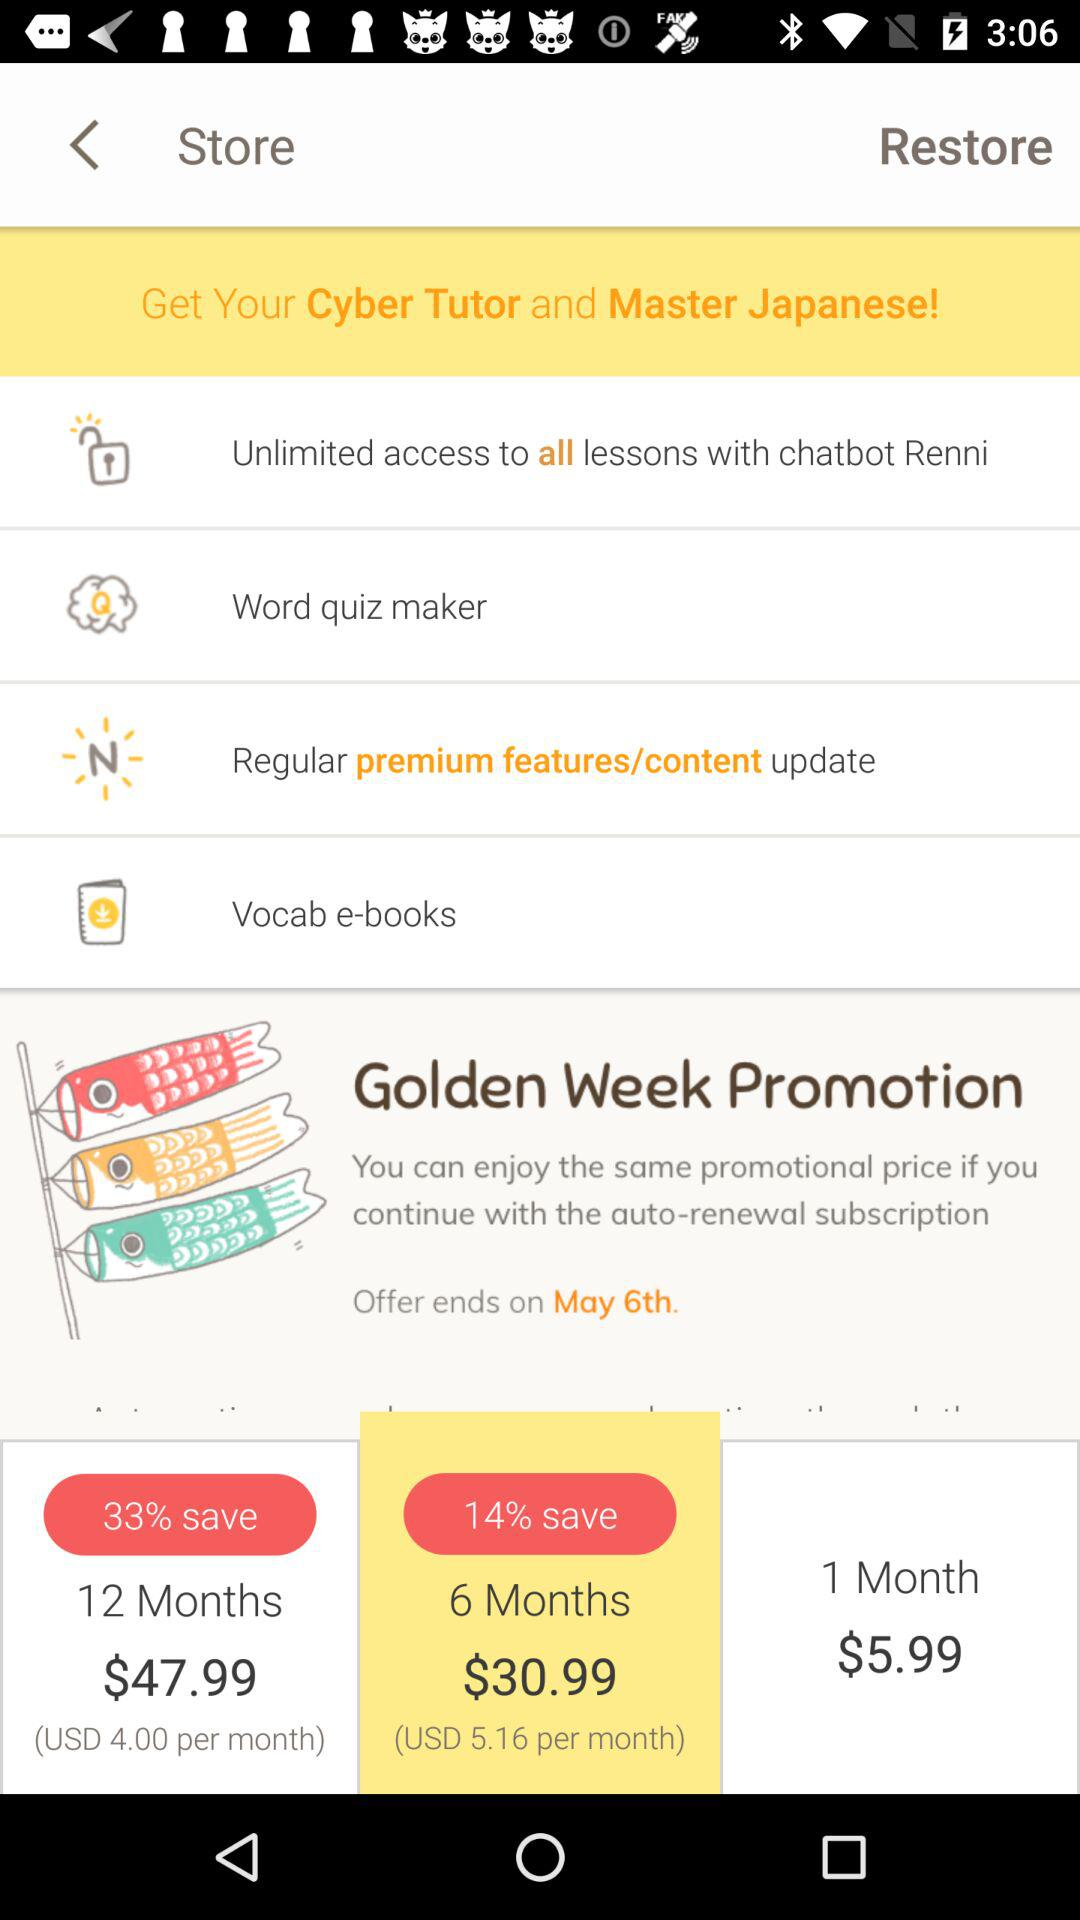How much more does the 12 month subscription cost than the 6 month subscription?
Answer the question using a single word or phrase. $17.00 